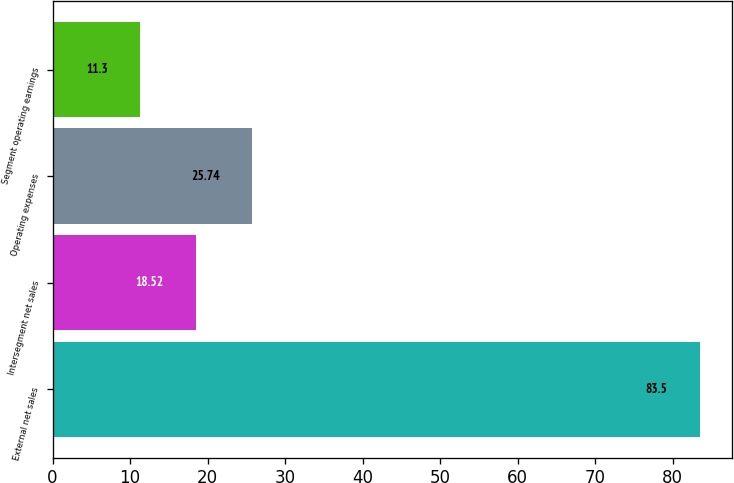<chart> <loc_0><loc_0><loc_500><loc_500><bar_chart><fcel>External net sales<fcel>Intersegment net sales<fcel>Operating expenses<fcel>Segment operating earnings<nl><fcel>83.5<fcel>18.52<fcel>25.74<fcel>11.3<nl></chart> 